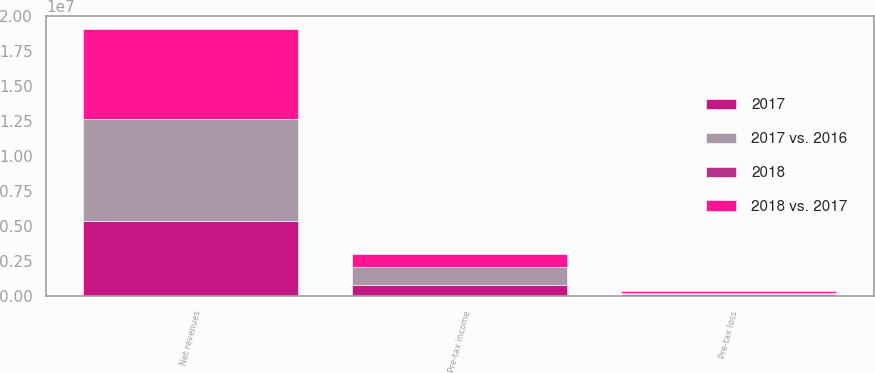Convert chart to OTSL. <chart><loc_0><loc_0><loc_500><loc_500><stacked_bar_chart><ecel><fcel>Net revenues<fcel>Pre-tax income<fcel>Pre-tax loss<nl><fcel>2017 vs. 2016<fcel>7.27432e+06<fcel>1.31066e+06<fcel>83201<nl><fcel>2018 vs. 2017<fcel>6.3711e+06<fcel>925346<fcel>169879<nl><fcel>2017<fcel>5.40506e+06<fcel>800643<fcel>148548<nl><fcel>2018<fcel>14<fcel>42<fcel>51<nl></chart> 